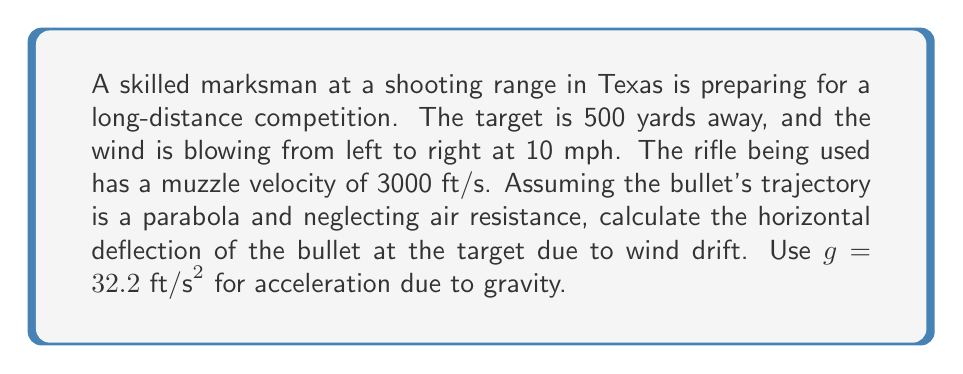Show me your answer to this math problem. Let's approach this step-by-step:

1) First, we need to calculate the time of flight for the bullet. The horizontal distance is 500 yards = 1500 ft.
   Time of flight, $t = \frac{\text{distance}}{\text{velocity}} = \frac{1500 \text{ ft}}{3000 \text{ ft/s}} = 0.5 \text{ s}$

2) Now, we need to convert the wind speed from mph to ft/s:
   $10 \text{ mph} = 10 \times \frac{5280 \text{ ft}}{3600 \text{ s}} = 14.67 \text{ ft/s}$

3) The wind will cause a constant acceleration on the bullet perpendicular to its path. This acceleration is:
   $a = \frac{\text{wind speed}}{\text{bullet speed}} \times g = \frac{14.67}{3000} \times 32.2 = 0.1577 \text{ ft/s²}$

4) The horizontal deflection due to wind can be calculated using the equation:
   $d = \frac{1}{2}at^2$

   where $d$ is the deflection, $a$ is the acceleration due to wind, and $t$ is the time of flight.

5) Plugging in our values:
   $d = \frac{1}{2} \times 0.1577 \text{ ft/s²} \times (0.5 \text{ s})^2 = 0.0197 \text{ ft}$

6) Converting to inches:
   $0.0197 \text{ ft} \times 12 \text{ in/ft} = 0.2364 \text{ in}$

Therefore, the horizontal deflection of the bullet at the target due to wind drift is approximately 0.24 inches.
Answer: 0.24 inches 